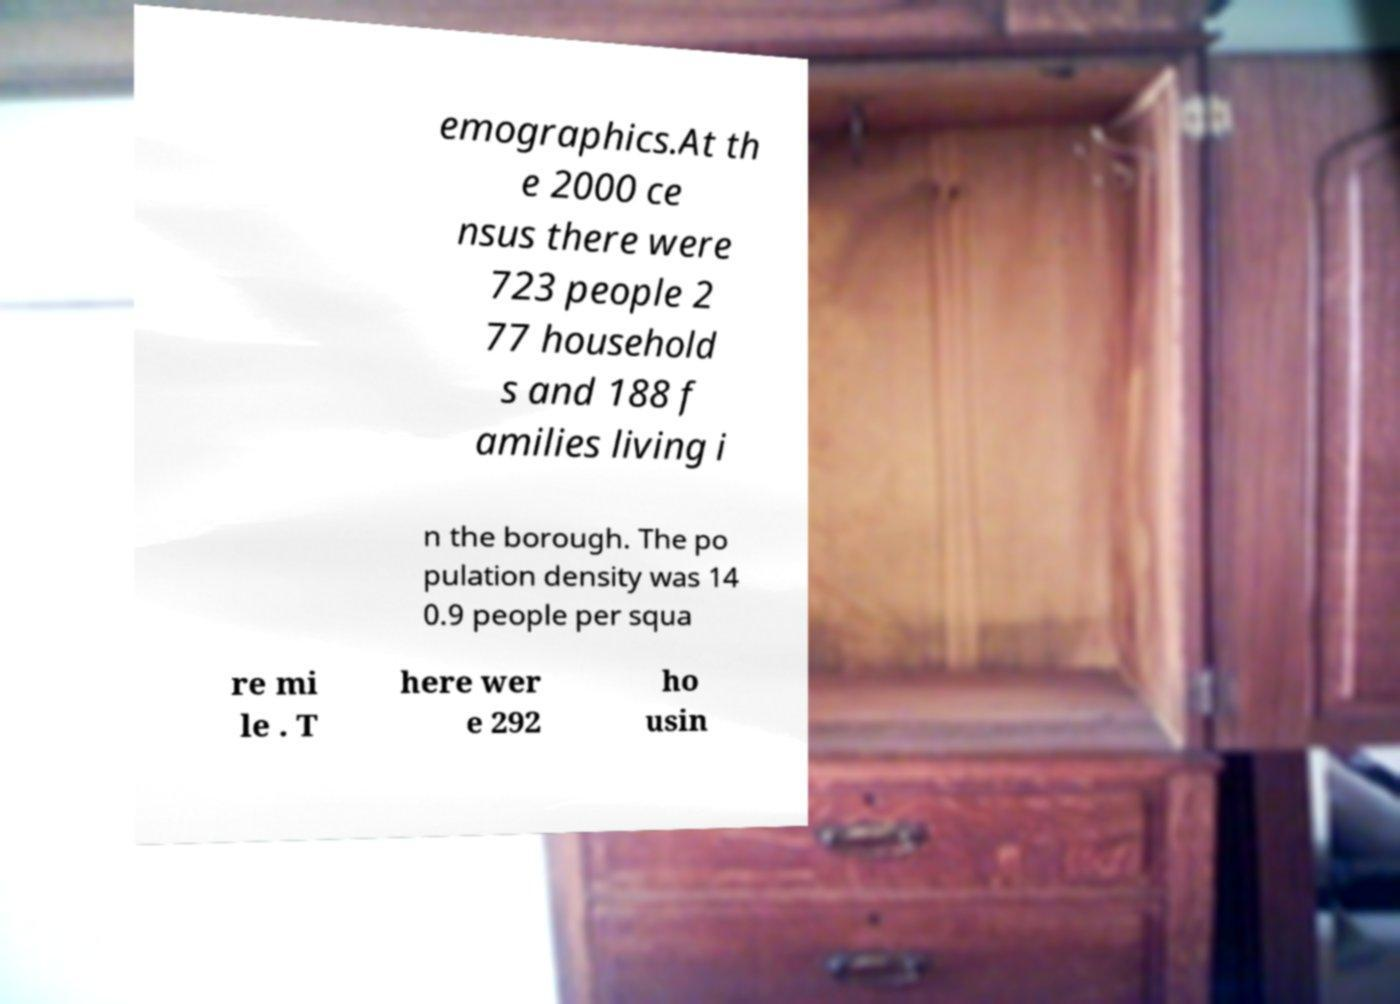There's text embedded in this image that I need extracted. Can you transcribe it verbatim? emographics.At th e 2000 ce nsus there were 723 people 2 77 household s and 188 f amilies living i n the borough. The po pulation density was 14 0.9 people per squa re mi le . T here wer e 292 ho usin 